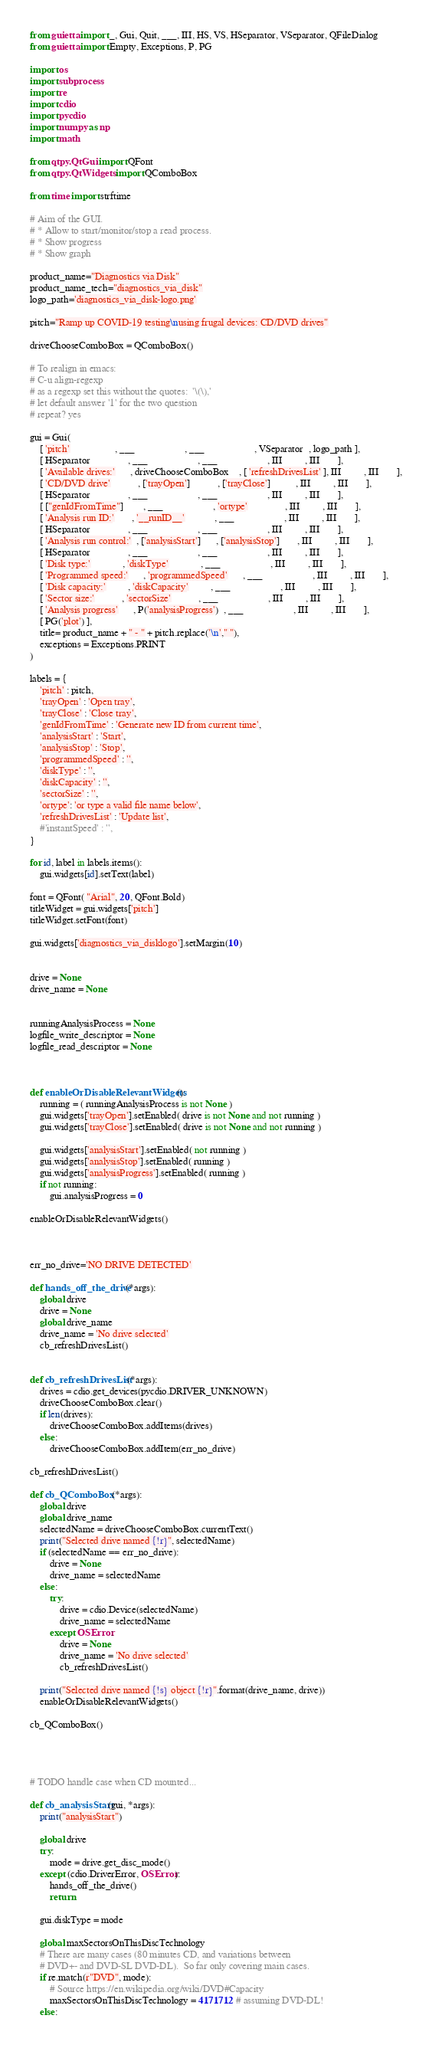<code> <loc_0><loc_0><loc_500><loc_500><_Python_>from guietta import _, Gui, Quit, ___, III, HS, VS, HSeparator, VSeparator, QFileDialog
from guietta import Empty, Exceptions, P, PG

import os
import subprocess
import re
import cdio
import pycdio
import numpy as np
import math

from qtpy.QtGui import QFont
from qtpy.QtWidgets import QComboBox

from time import strftime

# Aim of the GUI.
# * Allow to start/monitor/stop a read process.
# * Show progress
# * Show graph

product_name="Diagnostics via Disk"
product_name_tech="diagnostics_via_disk"
logo_path='diagnostics_via_disk-logo.png'

pitch="Ramp up COVID-19 testing\nusing frugal devices: CD/DVD drives"

driveChooseComboBox = QComboBox()

# To realign in emacs:
# C-u align-regexp
# as a regexp set this without the quotes:  '\(\),'
# let default answer '1' for the two question
# repeat? yes

gui = Gui(
    [ 'pitch'                  , ___                    , ___                    , VSeparator  , logo_path ],
    [ HSeparator               , ___                    , ___                    , III         , III       ],
    [ 'Available drives:'      , driveChooseComboBox    , [ 'refreshDrivesList' ], III         , III       ],
    [ 'CD/DVD drive'           , ['trayOpen']           , ['trayClose']          , III         , III       ],
    [ HSeparator               , ___                    , ___                    , III         , III       ],
    [ ["genIdFromTime"]        , ___                    , 'ortype'               , III         , III       ],
    [ 'Analysis run ID:'       , '__runID__'            , ___                    , III         , III       ],
    [ HSeparator               , ___                    , ___                    , III         , III       ],
    [ 'Analysis run control:'  , ['analysisStart']      , ['analysisStop']       , III         , III       ],
    [ HSeparator               , ___                    , ___                    , III         , III       ],
    [ 'Disk type:'             , 'diskType'             , ___                    , III         , III       ],
    [ 'Programmed speed:'      , 'programmedSpeed'      , ___                    , III         , III       ],
    [ 'Disk capacity:'         , 'diskCapacity'         , ___                    , III         , III       ],
    [ 'Sector size:'           , 'sectorSize'           , ___                    , III         , III       ],
    [ 'Analysis progress'      , P('analysisProgress')  , ___                    , III         , III       ],
    [ PG('plot') ],
    title= product_name + " - " + pitch.replace('\n'," "),
    exceptions = Exceptions.PRINT
)

labels = {
    'pitch' : pitch,
    'trayOpen' : 'Open tray',
    'trayClose' : 'Close tray',
    'genIdFromTime' : 'Generate new ID from current time',
    'analysisStart' : 'Start',
    'analysisStop' : 'Stop',
    'programmedSpeed' : '',
    'diskType' : '',
    'diskCapacity' : '',
    'sectorSize' : '',
    'ortype': 'or type a valid file name below',
    'refreshDrivesList' : 'Update list',
    #'instantSpeed' : '',
}

for id, label in labels.items():
    gui.widgets[id].setText(label)

font = QFont( "Arial", 20, QFont.Bold)
titleWidget = gui.widgets['pitch']
titleWidget.setFont(font)

gui.widgets['diagnostics_via_disklogo'].setMargin(10)


drive = None
drive_name = None


runningAnalysisProcess = None
logfile_write_descriptor = None
logfile_read_descriptor = None



def enableOrDisableRelevantWidgets():
    running = ( runningAnalysisProcess is not None )
    gui.widgets['trayOpen'].setEnabled( drive is not None and not running )
    gui.widgets['trayClose'].setEnabled( drive is not None and not running )

    gui.widgets['analysisStart'].setEnabled( not running )
    gui.widgets['analysisStop'].setEnabled( running )
    gui.widgets['analysisProgress'].setEnabled( running )
    if not running:
        gui.analysisProgress = 0

enableOrDisableRelevantWidgets()



err_no_drive='NO DRIVE DETECTED'

def hands_off_the_drive(*args):
    global drive
    drive = None
    global drive_name
    drive_name = 'No drive selected'
    cb_refreshDrivesList()


def cb_refreshDrivesList(*args):
    drives = cdio.get_devices(pycdio.DRIVER_UNKNOWN)
    driveChooseComboBox.clear()
    if len(drives):
        driveChooseComboBox.addItems(drives)
    else:
        driveChooseComboBox.addItem(err_no_drive)

cb_refreshDrivesList()

def cb_QComboBox(*args):
    global drive
    global drive_name
    selectedName = driveChooseComboBox.currentText()
    print("Selected drive named {!r}", selectedName)
    if (selectedName == err_no_drive):
        drive = None
        drive_name = selectedName
    else:
        try:
            drive = cdio.Device(selectedName)
            drive_name = selectedName
        except OSError:
            drive = None
            drive_name = 'No drive selected'
            cb_refreshDrivesList()

    print("Selected drive named {!s} object {!r}".format(drive_name, drive))
    enableOrDisableRelevantWidgets()

cb_QComboBox()




# TODO handle case when CD mounted...

def cb_analysisStart(gui, *args):
    print("analysisStart")

    global drive
    try:
        mode = drive.get_disc_mode()
    except (cdio.DriverError, OSError):
        hands_off_the_drive()
        return

    gui.diskType = mode

    global maxSectorsOnThisDiscTechnology
    # There are many cases (80 minutes CD, and variations between
    # DVD+- and DVD-SL DVD-DL).  So far only covering main cases.
    if re.match(r"DVD", mode):
        # Source https://en.wikipedia.org/wiki/DVD#Capacity
        maxSectorsOnThisDiscTechnology = 4171712 # assuming DVD-DL!
    else:</code> 